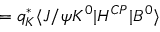<formula> <loc_0><loc_0><loc_500><loc_500>= q _ { K } ^ { \ast } \langle J / \psi K ^ { 0 } | H ^ { C P } | B ^ { 0 } \rangle</formula> 